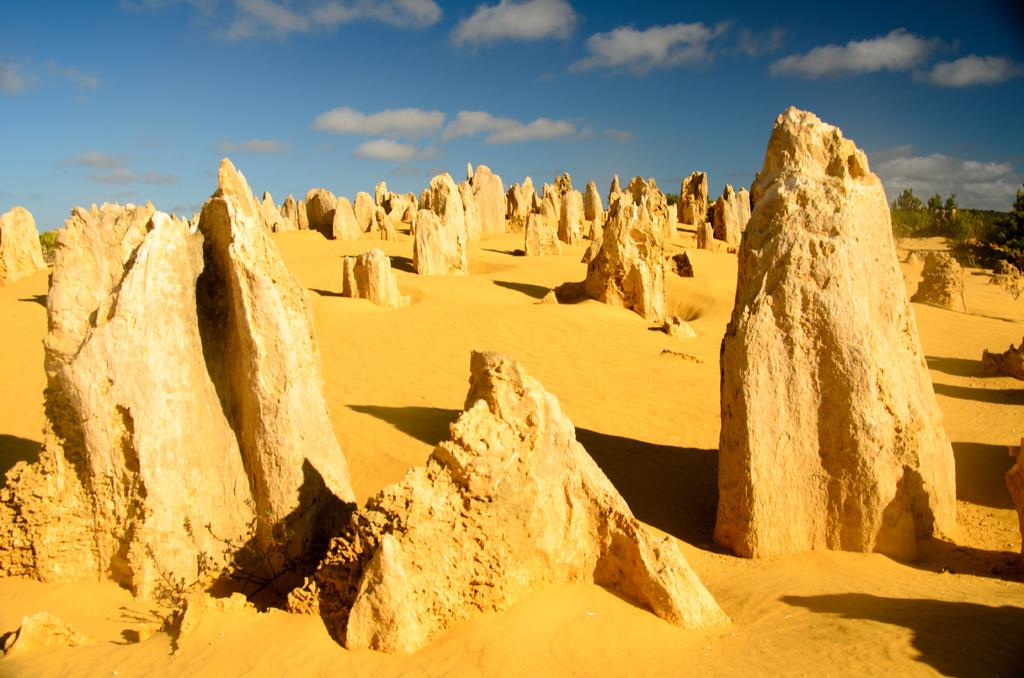What type of natural objects can be seen in the sand in the image? There are big stones in the sand in the image. What can be seen on the right side of the image? There are plants on the right side of the image. What is visible at the top of the image? The sky is visible at the top of the image. Who is the guide in the image? There is no guide present in the image. What parcel is being delivered in the image? There is: There is no parcel present in the image. 